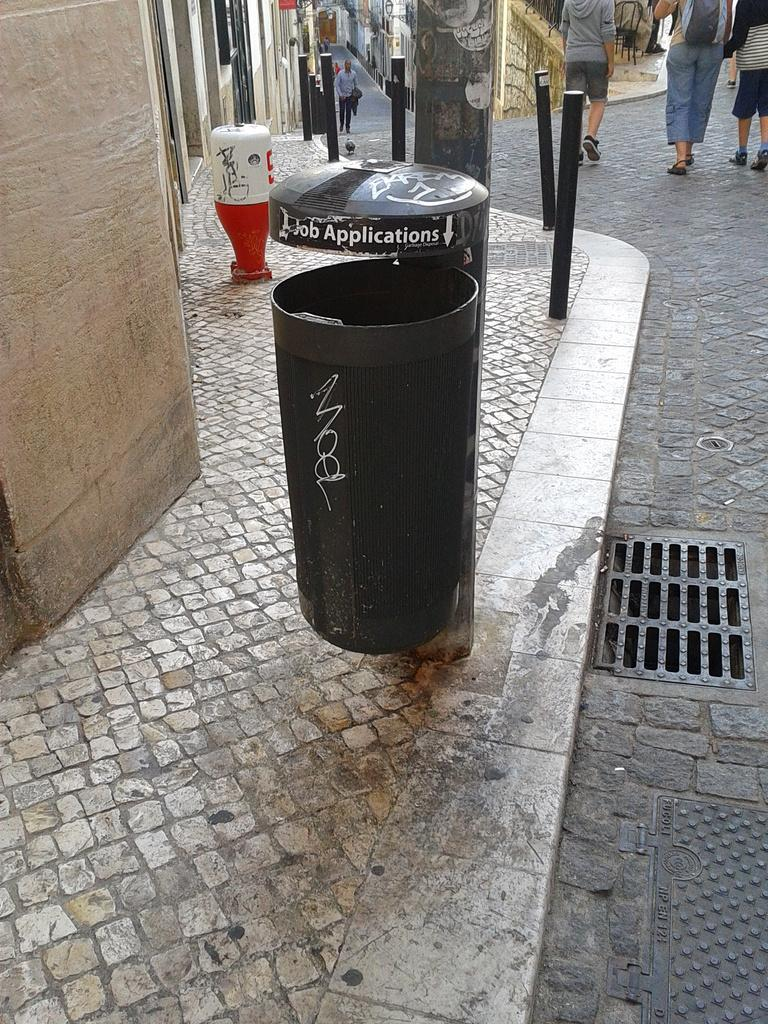<image>
Describe the image concisely. A trash can has the words "job applications" at the top of it. 